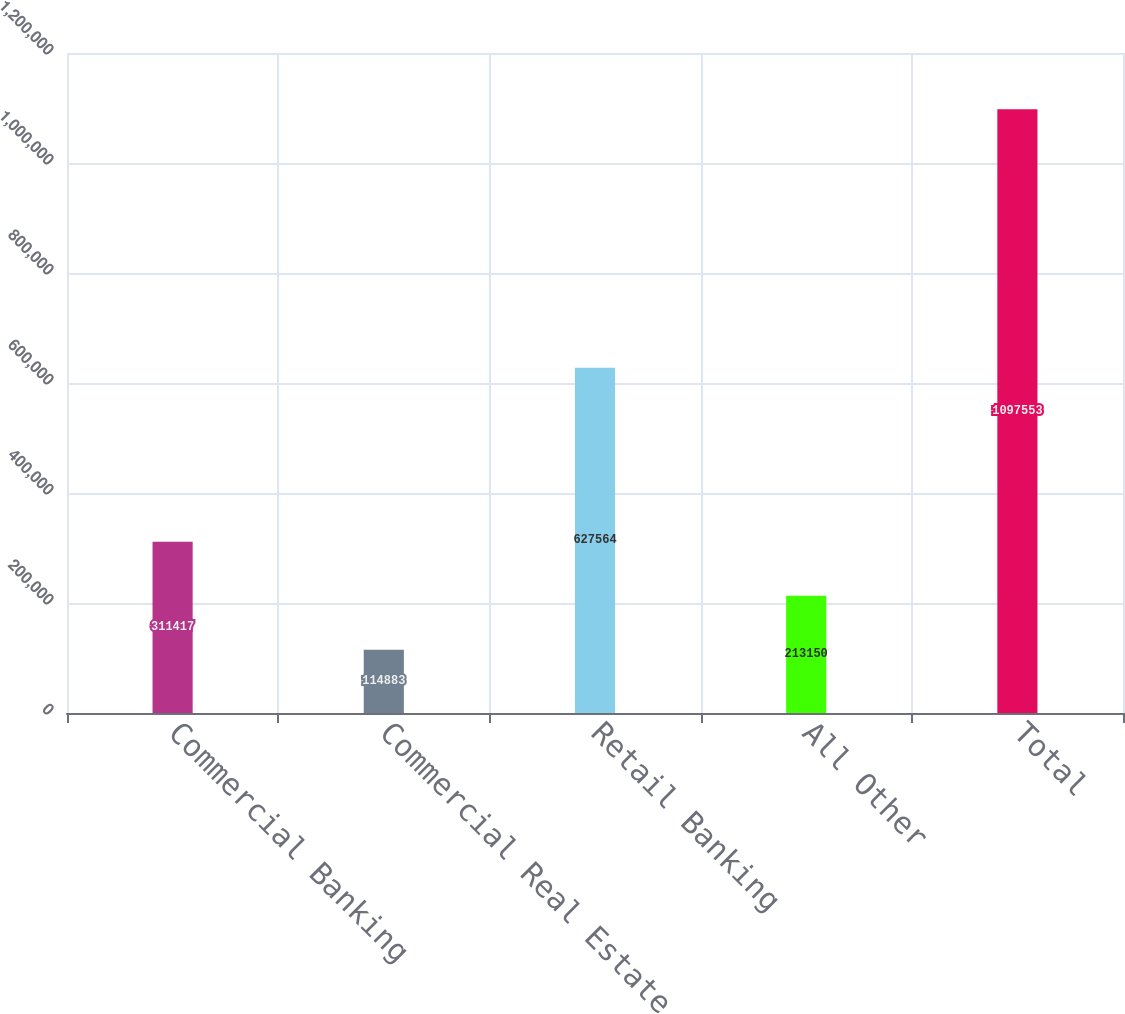Convert chart. <chart><loc_0><loc_0><loc_500><loc_500><bar_chart><fcel>Commercial Banking<fcel>Commercial Real Estate<fcel>Retail Banking<fcel>All Other<fcel>Total<nl><fcel>311417<fcel>114883<fcel>627564<fcel>213150<fcel>1.09755e+06<nl></chart> 